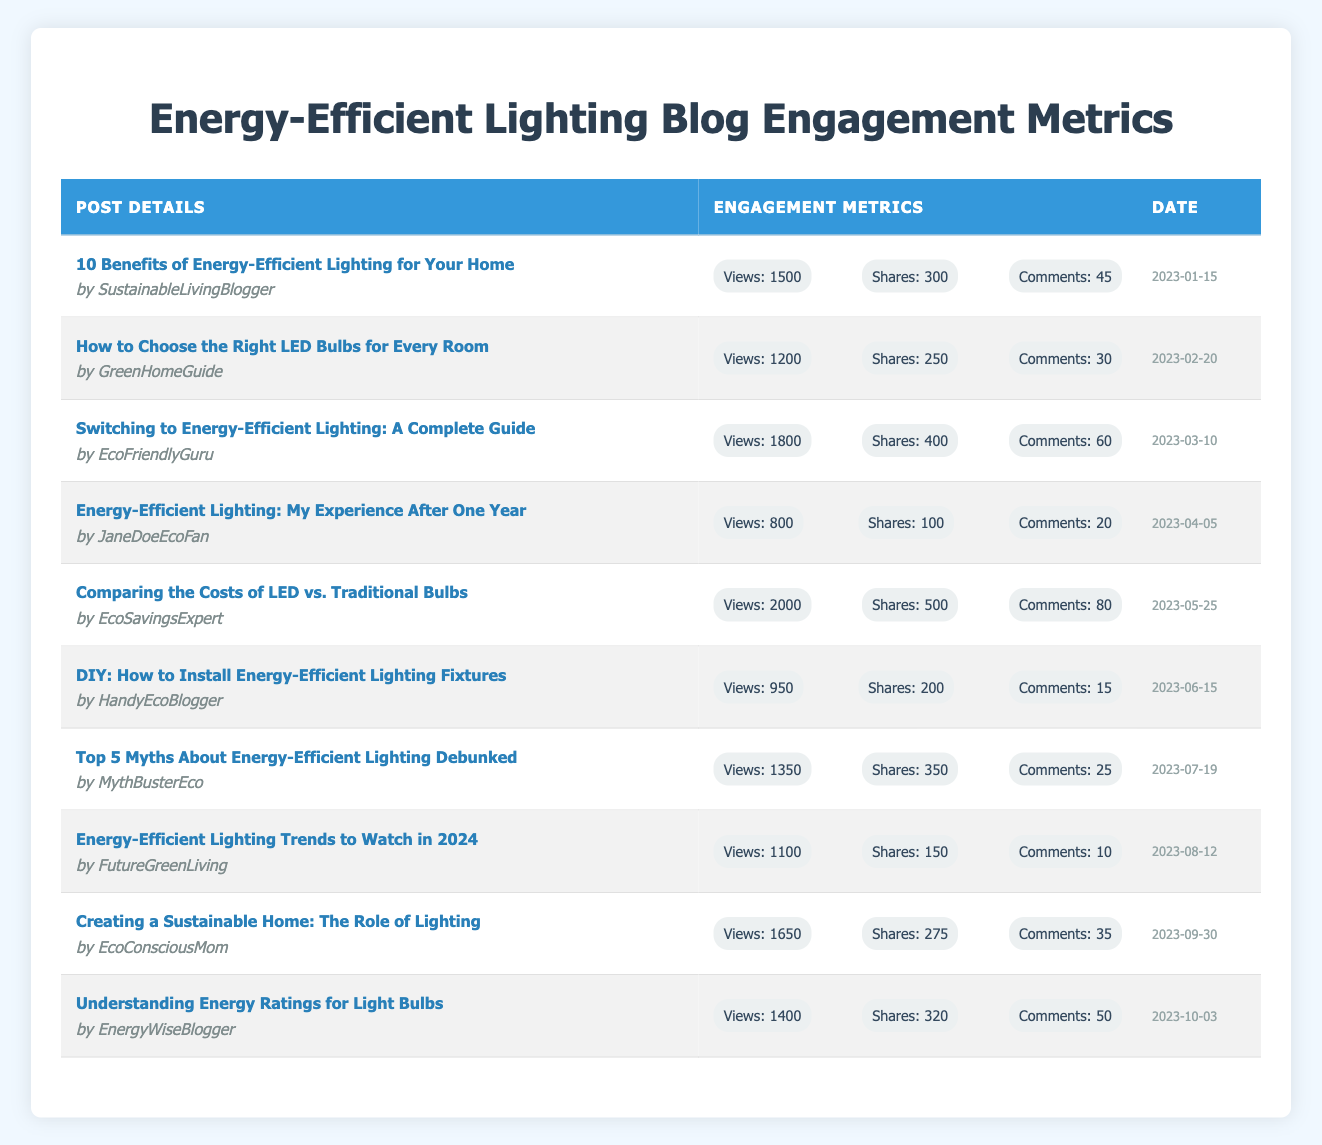What post had the highest number of views? The post titled "Comparing the Costs of LED vs. Traditional Bulbs" has 2000 views, which is the highest among all the posts listed in the table.
Answer: 2000 views Which author received the most shares for their post? The author of the post "Comparing the Costs of LED vs. Traditional Bulbs" has the highest shares, totaling 500 shares.
Answer: 500 shares What is the total number of comments across all posts? Summing up the comments from each post: (45 + 30 + 60 + 20 + 80 + 15 + 25 + 10 + 35 + 50) gives a total of  450 comments across all posts.
Answer: 450 comments Which post has the least engagement in terms of shares? "DIY: How to Install Energy-Efficient Lighting Fixtures" has the least shares, totaling 200 shares, compared to other posts.
Answer: 200 shares What is the average number of views for the posts? There are 10 posts in total. Adding all views gives (1500 + 1200 + 1800 + 800 + 2000 + 950 + 1350 + 1100 + 1650 + 1400) =  15500. Dividing by 10 (posts) gives an average of 1550 views.
Answer: 1550 views Did any post receive more than 400 shares? Yes, the post "Comparing the Costs of LED vs. Traditional Bulbs" received 500 shares, which is more than 400.
Answer: Yes Which post had the highest engagement in terms of comments? The post titled "Comparing the Costs of LED vs. Traditional Bulbs" had the highest engagement with 80 comments.
Answer: 80 comments What is the difference in views between the post with the most views and the post with the least views? The post with the most views is "Comparing the Costs of LED vs. Traditional Bulbs" (2000 views) and the one with the least views is "Energy-Efficient Lighting: My Experience After One Year" (800 views). The difference is 2000 - 800 = 1200 views.
Answer: 1200 views What date was the post with the fewest comments published? The post with the fewest comments, "Energy-Efficient Lighting Trends to Watch in 2024", was published on 2023-08-12.
Answer: 2023-08-12 How many posts received more than 300 views? All 10 posts received more than 300 views, as even the lowest views (800) are above that threshold.
Answer: 10 posts 